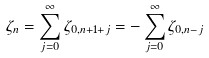Convert formula to latex. <formula><loc_0><loc_0><loc_500><loc_500>\zeta _ { n } = \sum _ { j = 0 } ^ { \infty } \zeta _ { 0 , n + 1 + j } = - \sum _ { j = 0 } ^ { \infty } \zeta _ { 0 , n - j }</formula> 